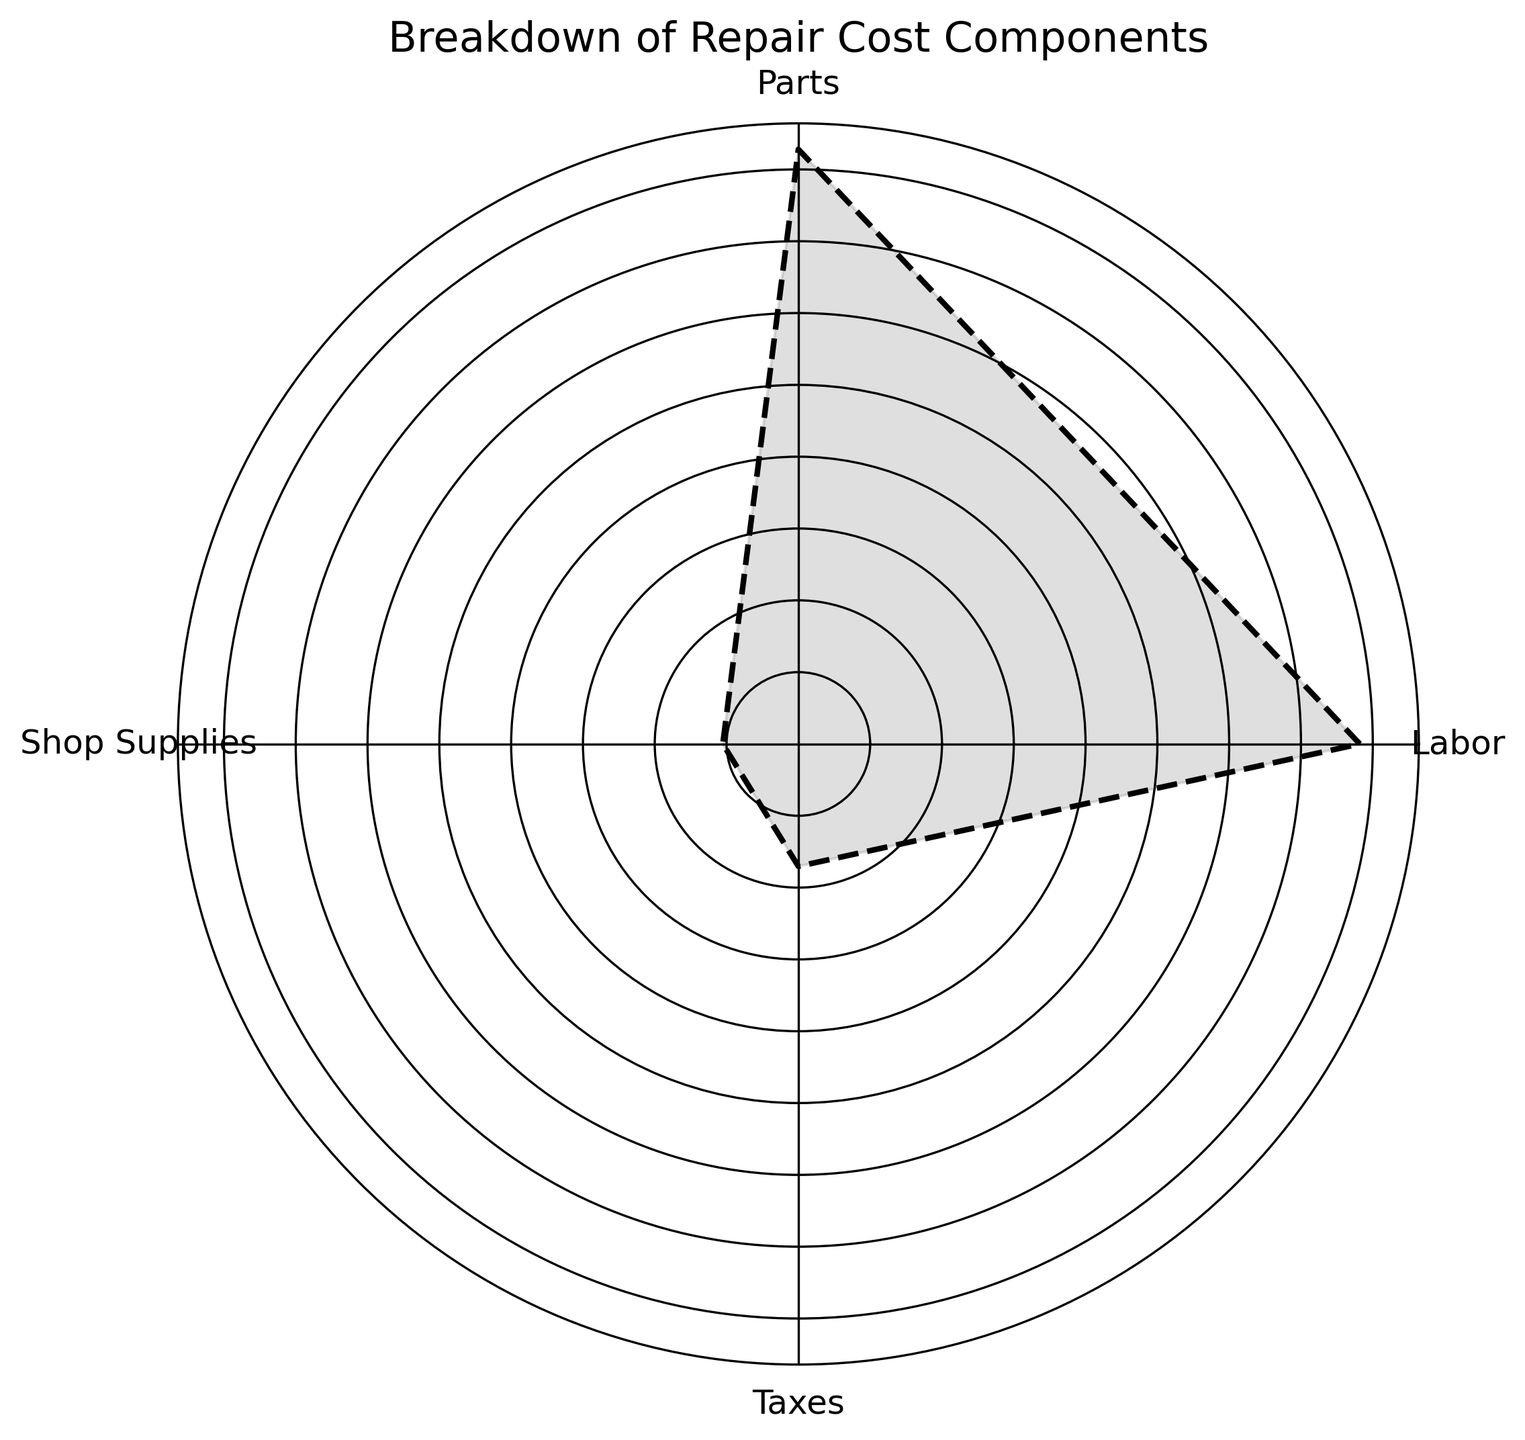What is the total cost contributed by taxes? To find the total cost contributed by taxes, sum up all the tax values from the plot.
Answer: 428 Which component has the highest total cost? Compare the heights or lengths of all components' sectors. The tallest or longest one represents the component with the highest total cost.
Answer: Parts Which two components combined exceed the total cost of labor? Find the cost of Labor, then sum combinations of the other components' costs from the plot. Compare the sums to the total cost of Labor.
Answer: Parts and Shop Supplies How does the Shop Supplies cost compare to the Taxes cost? Compare the heights or lengths of the Shop Supplies and Taxes sectors. Determine which is taller or longer to see which cost is higher.
Answer: Taxes cost more than Shop Supplies What is the average cost of the parts component across all instances? Sum the cost associated with the parts from the plot and divide by the number of occurrences.
Answer: 296 Which component contributes the least to the total cost? Identify the sector with the smallest height or length on the plot, which represents the component with the least cost.
Answer: Shop Supplies If the labor cost decreased by 10%, what would the new total cost for labor be? Calculate 10% of the total labor cost from the plot and subtract that amount from the original total cost.
Answer: 1777 - 177.7 = 1599.3 How does the combined cost of parts and labor compare to the total cost of taxes and shop supplies? Sum the costs for parts and labor, then sum the costs for taxes and shop supplies, and compare these two sums.
Answer: Parts + Labor: 2070, Taxes + Shop Supplies: 486. The former is significantly higher What fraction of the total cost is contributed by the labor component? Divide the total cost of labor by the sum of costs of all components, and express it as a fraction or percentage.
Answer: 1777 / (1777 + 2070 + 428 + 286) ≈ 0.34 or 34% If the cost of shop supplies increases by 20%, what will be the new total cost for shop supplies? Calculate 20% of the current total cost of shop supplies from the plot and add that amount to the original total cost.
Answer: 286 + 57.2 = 343.2 